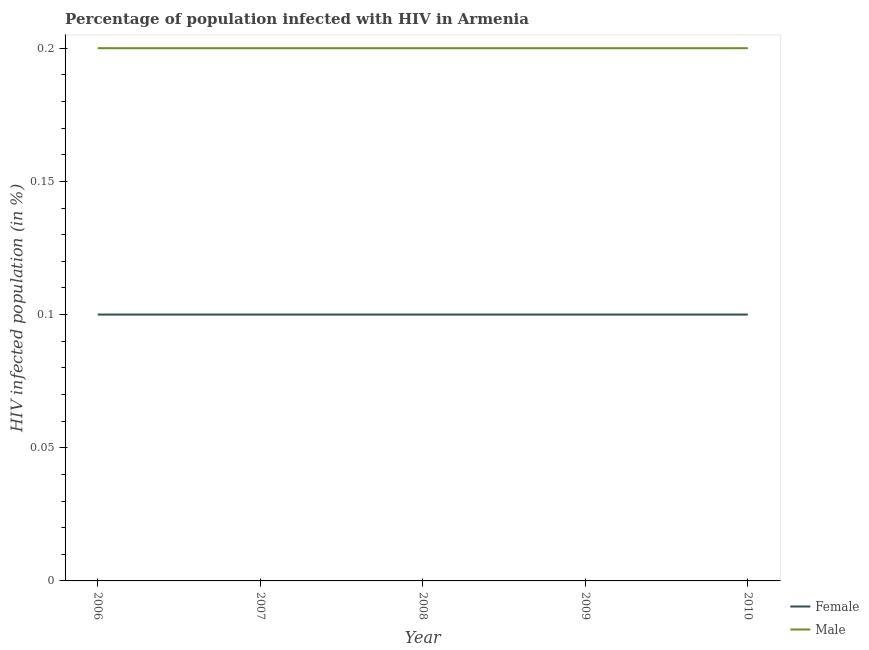How many different coloured lines are there?
Provide a short and direct response. 2. Across all years, what is the minimum percentage of males who are infected with hiv?
Provide a short and direct response. 0.2. In which year was the percentage of females who are infected with hiv maximum?
Provide a succinct answer. 2006. In which year was the percentage of females who are infected with hiv minimum?
Offer a terse response. 2006. What is the difference between the percentage of females who are infected with hiv in 2006 and that in 2010?
Provide a succinct answer. 0. What is the average percentage of males who are infected with hiv per year?
Your answer should be very brief. 0.2. What is the ratio of the percentage of males who are infected with hiv in 2008 to that in 2010?
Make the answer very short. 1. Is the percentage of males who are infected with hiv in 2008 less than that in 2009?
Ensure brevity in your answer.  No. Is the difference between the percentage of females who are infected with hiv in 2007 and 2009 greater than the difference between the percentage of males who are infected with hiv in 2007 and 2009?
Make the answer very short. No. What is the difference between the highest and the second highest percentage of females who are infected with hiv?
Keep it short and to the point. 0. What is the difference between the highest and the lowest percentage of females who are infected with hiv?
Keep it short and to the point. 0. In how many years, is the percentage of females who are infected with hiv greater than the average percentage of females who are infected with hiv taken over all years?
Provide a succinct answer. 0. Is the sum of the percentage of females who are infected with hiv in 2008 and 2009 greater than the maximum percentage of males who are infected with hiv across all years?
Provide a short and direct response. No. Does the percentage of females who are infected with hiv monotonically increase over the years?
Offer a very short reply. No. Is the percentage of females who are infected with hiv strictly greater than the percentage of males who are infected with hiv over the years?
Make the answer very short. No. Is the percentage of males who are infected with hiv strictly less than the percentage of females who are infected with hiv over the years?
Your answer should be compact. No. How many lines are there?
Keep it short and to the point. 2. What is the difference between two consecutive major ticks on the Y-axis?
Make the answer very short. 0.05. Are the values on the major ticks of Y-axis written in scientific E-notation?
Provide a succinct answer. No. Does the graph contain any zero values?
Your answer should be compact. No. Does the graph contain grids?
Offer a terse response. No. What is the title of the graph?
Make the answer very short. Percentage of population infected with HIV in Armenia. What is the label or title of the Y-axis?
Ensure brevity in your answer.  HIV infected population (in %). What is the HIV infected population (in %) of Female in 2008?
Give a very brief answer. 0.1. What is the HIV infected population (in %) in Male in 2009?
Your answer should be very brief. 0.2. What is the HIV infected population (in %) of Female in 2010?
Make the answer very short. 0.1. What is the HIV infected population (in %) in Male in 2010?
Your answer should be compact. 0.2. Across all years, what is the minimum HIV infected population (in %) of Female?
Keep it short and to the point. 0.1. Across all years, what is the minimum HIV infected population (in %) of Male?
Keep it short and to the point. 0.2. What is the total HIV infected population (in %) in Female in the graph?
Offer a very short reply. 0.5. What is the difference between the HIV infected population (in %) in Female in 2006 and that in 2008?
Keep it short and to the point. 0. What is the difference between the HIV infected population (in %) in Male in 2006 and that in 2009?
Offer a very short reply. 0. What is the difference between the HIV infected population (in %) of Female in 2006 and that in 2010?
Keep it short and to the point. 0. What is the difference between the HIV infected population (in %) of Female in 2007 and that in 2008?
Make the answer very short. 0. What is the difference between the HIV infected population (in %) in Male in 2007 and that in 2008?
Your answer should be very brief. 0. What is the difference between the HIV infected population (in %) of Female in 2007 and that in 2009?
Make the answer very short. 0. What is the difference between the HIV infected population (in %) in Male in 2007 and that in 2010?
Ensure brevity in your answer.  0. What is the difference between the HIV infected population (in %) in Female in 2008 and that in 2009?
Offer a terse response. 0. What is the difference between the HIV infected population (in %) of Male in 2008 and that in 2009?
Give a very brief answer. 0. What is the difference between the HIV infected population (in %) in Female in 2008 and that in 2010?
Keep it short and to the point. 0. What is the difference between the HIV infected population (in %) of Female in 2006 and the HIV infected population (in %) of Male in 2007?
Your answer should be very brief. -0.1. What is the difference between the HIV infected population (in %) of Female in 2006 and the HIV infected population (in %) of Male in 2010?
Give a very brief answer. -0.1. What is the difference between the HIV infected population (in %) of Female in 2008 and the HIV infected population (in %) of Male in 2009?
Your answer should be very brief. -0.1. What is the difference between the HIV infected population (in %) of Female in 2008 and the HIV infected population (in %) of Male in 2010?
Your answer should be compact. -0.1. What is the difference between the HIV infected population (in %) of Female in 2009 and the HIV infected population (in %) of Male in 2010?
Your answer should be compact. -0.1. What is the average HIV infected population (in %) in Male per year?
Make the answer very short. 0.2. In the year 2006, what is the difference between the HIV infected population (in %) in Female and HIV infected population (in %) in Male?
Provide a short and direct response. -0.1. In the year 2007, what is the difference between the HIV infected population (in %) in Female and HIV infected population (in %) in Male?
Offer a very short reply. -0.1. In the year 2009, what is the difference between the HIV infected population (in %) in Female and HIV infected population (in %) in Male?
Provide a succinct answer. -0.1. In the year 2010, what is the difference between the HIV infected population (in %) of Female and HIV infected population (in %) of Male?
Your response must be concise. -0.1. What is the ratio of the HIV infected population (in %) in Male in 2006 to that in 2007?
Make the answer very short. 1. What is the ratio of the HIV infected population (in %) in Female in 2006 to that in 2008?
Give a very brief answer. 1. What is the ratio of the HIV infected population (in %) of Female in 2006 to that in 2009?
Your answer should be compact. 1. What is the ratio of the HIV infected population (in %) in Female in 2007 to that in 2009?
Your response must be concise. 1. What is the ratio of the HIV infected population (in %) in Male in 2007 to that in 2009?
Your response must be concise. 1. What is the ratio of the HIV infected population (in %) of Male in 2007 to that in 2010?
Ensure brevity in your answer.  1. What is the ratio of the HIV infected population (in %) in Female in 2008 to that in 2009?
Offer a very short reply. 1. What is the ratio of the HIV infected population (in %) in Male in 2008 to that in 2009?
Ensure brevity in your answer.  1. What is the ratio of the HIV infected population (in %) of Female in 2008 to that in 2010?
Your answer should be very brief. 1. What is the ratio of the HIV infected population (in %) of Male in 2008 to that in 2010?
Offer a terse response. 1. What is the difference between the highest and the second highest HIV infected population (in %) of Female?
Your answer should be compact. 0. What is the difference between the highest and the lowest HIV infected population (in %) in Male?
Your answer should be compact. 0. 